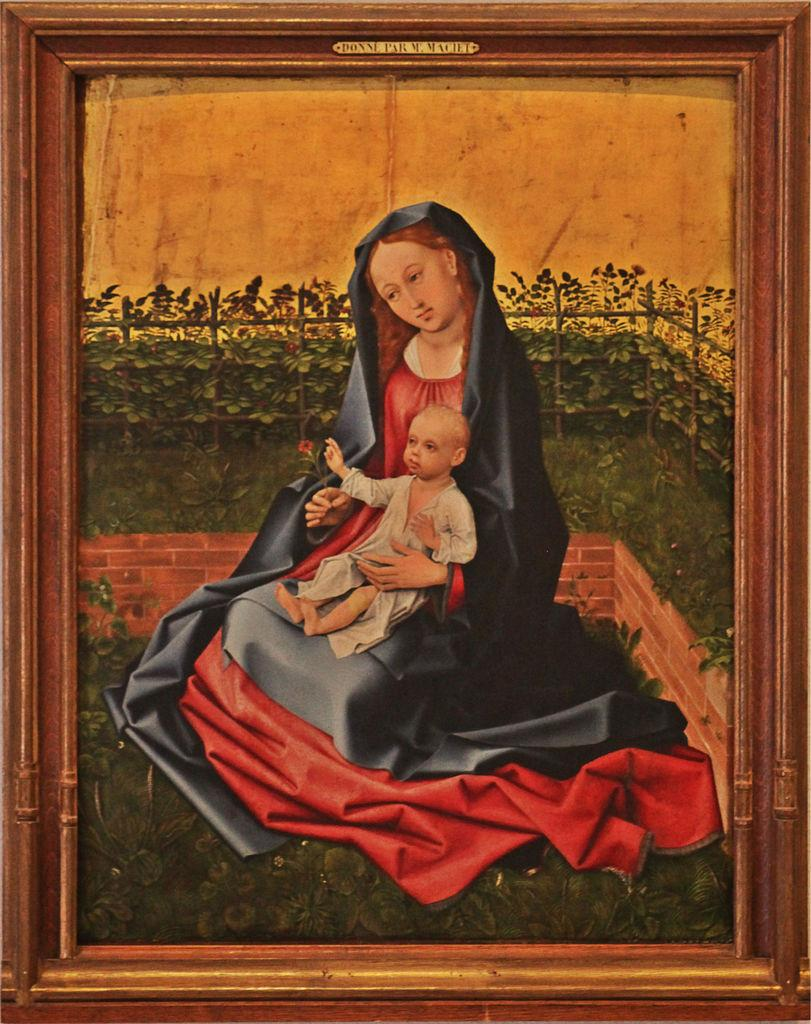<image>
Summarize the visual content of the image. A pieta type of picture with a gold plaque at the top of the frame starting wiht the word Donne. 